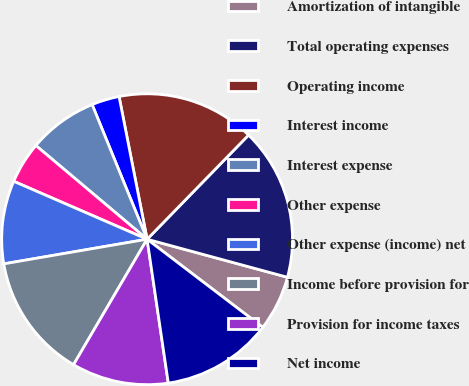<chart> <loc_0><loc_0><loc_500><loc_500><pie_chart><fcel>Amortization of intangible<fcel>Total operating expenses<fcel>Operating income<fcel>Interest income<fcel>Interest expense<fcel>Other expense<fcel>Other expense (income) net<fcel>Income before provision for<fcel>Provision for income taxes<fcel>Net income<nl><fcel>6.15%<fcel>16.92%<fcel>15.38%<fcel>3.08%<fcel>7.69%<fcel>4.62%<fcel>9.23%<fcel>13.85%<fcel>10.77%<fcel>12.31%<nl></chart> 